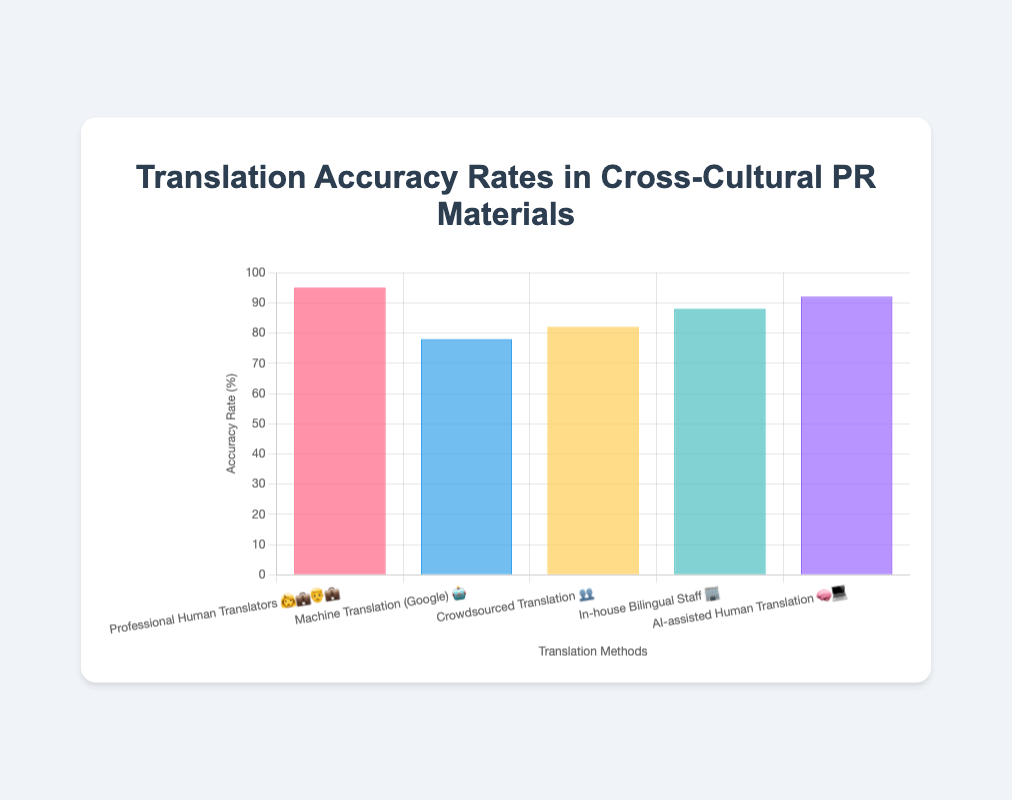What is the title of the figure? The title of the figure is displayed at the top and reads "Translation Accuracy Rates in Cross-Cultural PR Materials"
Answer: Translation Accuracy Rates in Cross-Cultural PR Materials Which translation method has the highest accuracy rate? The bar with the highest length represents "Professional Human Translators 👩‍💼👨‍💼," at the far left of the chart, indicating an accuracy rate of 95%
Answer: Professional Human Translators 👩‍💼👨‍💼 Which translation method has the lowest accuracy rate? The bar with the shortest length represents "Machine Translation (Google) 🤖," located second from the left, indicating an accuracy rate of 78%
Answer: Machine Translation (Google) 🤖 What is the accuracy rate of AI-assisted Human Translation 🧠💻? The label "AI-assisted Human Translation 🧠💻" corresponds to a bar with a length reaching 92% on the y-axis
Answer: 92% How much higher is the accuracy rate of "Professional Human Translators 👩‍💼👨‍💼" compared to "Machine Translation (Google) 🤖"? The accuracy rate of Professional Human Translators 👩‍💼👨‍💼 is 95%, and for Machine Translation (Google) 🤖, it is 78%. The difference is calculated as 95% - 78% = 17%
Answer: 17% Rank all the translation methods by accuracy rate from highest to lowest. Sorting the bars based on their lengths from highest to lowest gives: 1. Professional Human Translators 👩‍💼👨‍💼 (95%), 2. AI-assisted Human Translation 🧠💻 (92%), 3. In-house Bilingual Staff 🏢 (88%), 4. Crowdsourced Translation 👥 (82%), 5. Machine Translation (Google) 🤖 (78%)
Answer: Professional Human Translators 👩‍💼👨‍💼 > AI-assisted Human Translation 🧠💻 > In-house Bilingual Staff 🏢 > Crowdsourced Translation 👥 > Machine Translation (Google) 🤖 Which two methods have the smallest difference in accuracy rates? Looking at the bar lengths and comparing their differences, the smallest difference is between "Crowdsourced Translation 👥" at 82% and "In-house Bilingual Staff 🏢" at 88%, which is a difference of 6%
Answer: Crowdsourced Translation 👥 and In-house Bilingual Staff 🏢 What is the average accuracy rate across all translation methods? Summing the accuracy rates: 95 + 78 + 82 + 88 + 92 = 435. Dividing by 5 methods, the average is 435 / 5 = 87%
Answer: 87% What is the total accuracy percentage for all translation methods combined? Adding together all the accuracy rates: 95 + 78 + 82 + 88 + 92 = 435%
Answer: 435% If you were to choose the top two most accurate methods, what would they be? The top two bars in terms of length correspond to "Professional Human Translators 👩‍💼👨‍💼" at 95% and "AI-assisted Human Translation 🧠💻" at 92%
Answer: Professional Human Translators 👩‍💼👨‍💼 and AI-assisted Human Translation 🧠💻 